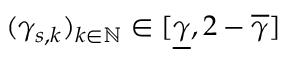Convert formula to latex. <formula><loc_0><loc_0><loc_500><loc_500>( \gamma _ { s , k } ) _ { k \in \mathbb { N } } \in [ \underline { \gamma } , 2 - \overline { \gamma } ]</formula> 